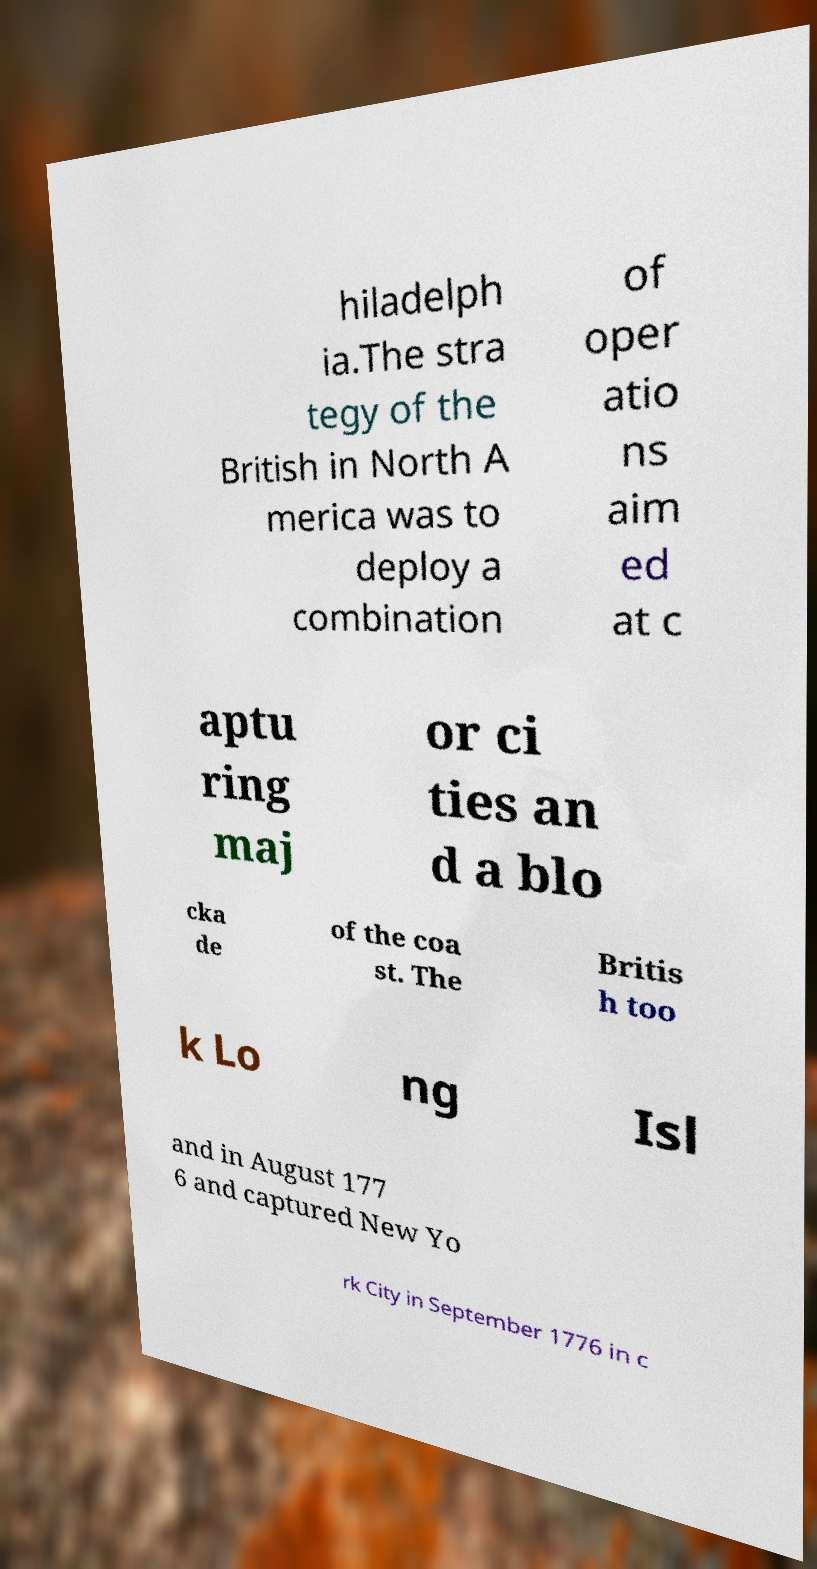Could you extract and type out the text from this image? hiladelph ia.The stra tegy of the British in North A merica was to deploy a combination of oper atio ns aim ed at c aptu ring maj or ci ties an d a blo cka de of the coa st. The Britis h too k Lo ng Isl and in August 177 6 and captured New Yo rk City in September 1776 in c 